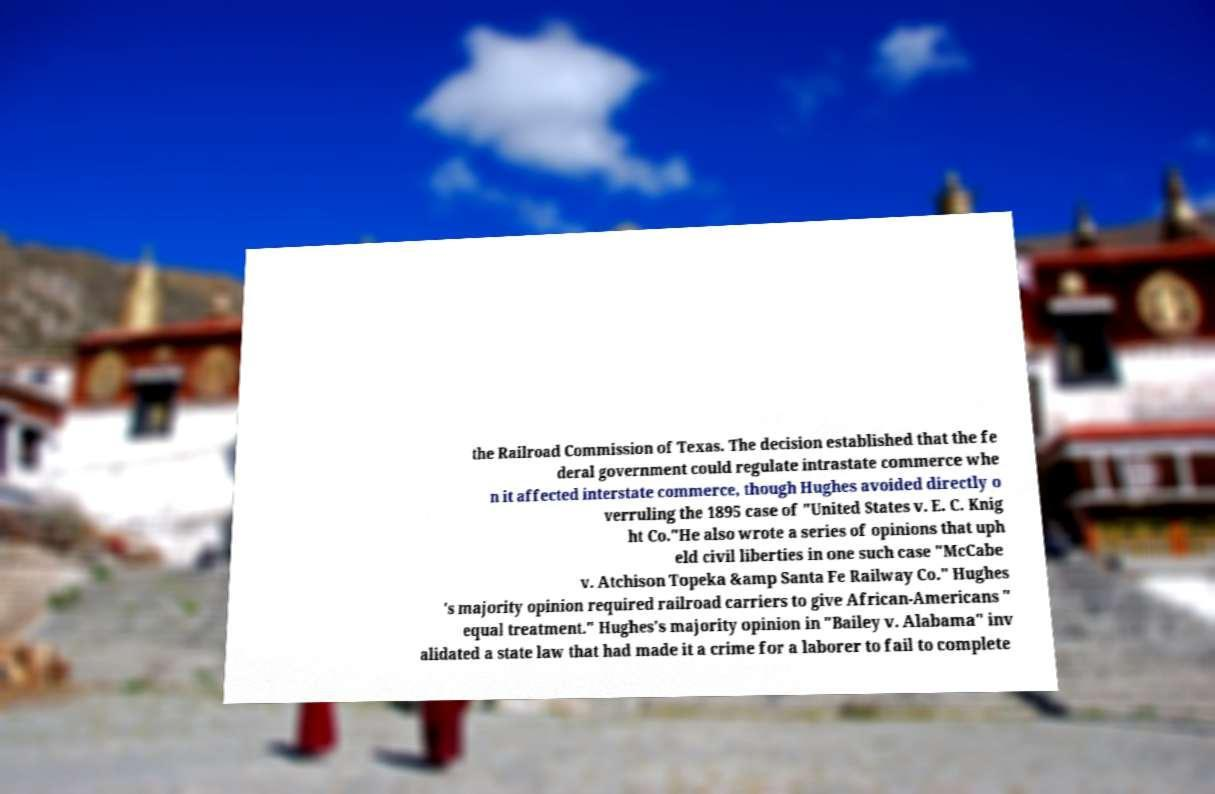Could you extract and type out the text from this image? the Railroad Commission of Texas. The decision established that the fe deral government could regulate intrastate commerce whe n it affected interstate commerce, though Hughes avoided directly o verruling the 1895 case of "United States v. E. C. Knig ht Co."He also wrote a series of opinions that uph eld civil liberties in one such case "McCabe v. Atchison Topeka &amp Santa Fe Railway Co." Hughes 's majority opinion required railroad carriers to give African-Americans " equal treatment." Hughes's majority opinion in "Bailey v. Alabama" inv alidated a state law that had made it a crime for a laborer to fail to complete 